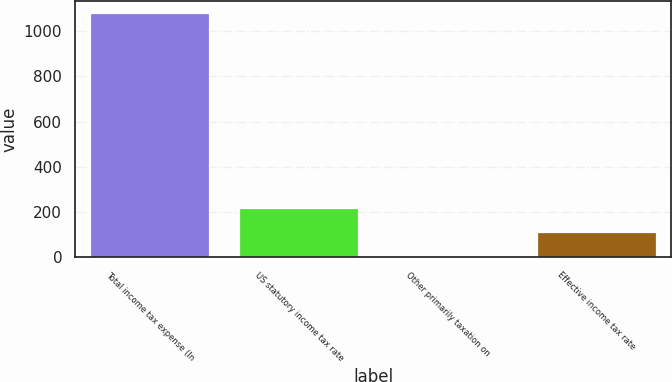<chart> <loc_0><loc_0><loc_500><loc_500><bar_chart><fcel>Total income tax expense (In<fcel>US statutory income tax rate<fcel>Other primarily taxation on<fcel>Effective income tax rate<nl><fcel>1078<fcel>218<fcel>3<fcel>110.5<nl></chart> 